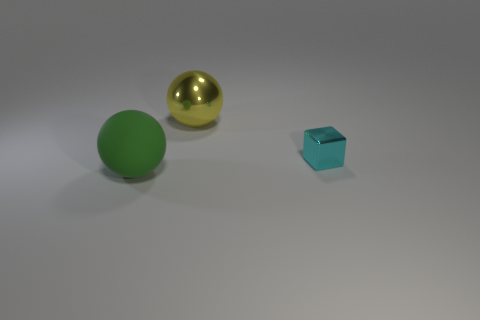Add 3 yellow matte cylinders. How many objects exist? 6 Add 3 cyan metal objects. How many cyan metal objects exist? 4 Subtract 0 yellow cubes. How many objects are left? 3 Subtract all balls. How many objects are left? 1 Subtract all large green objects. Subtract all small cyan metal objects. How many objects are left? 1 Add 3 small cyan metallic blocks. How many small cyan metallic blocks are left? 4 